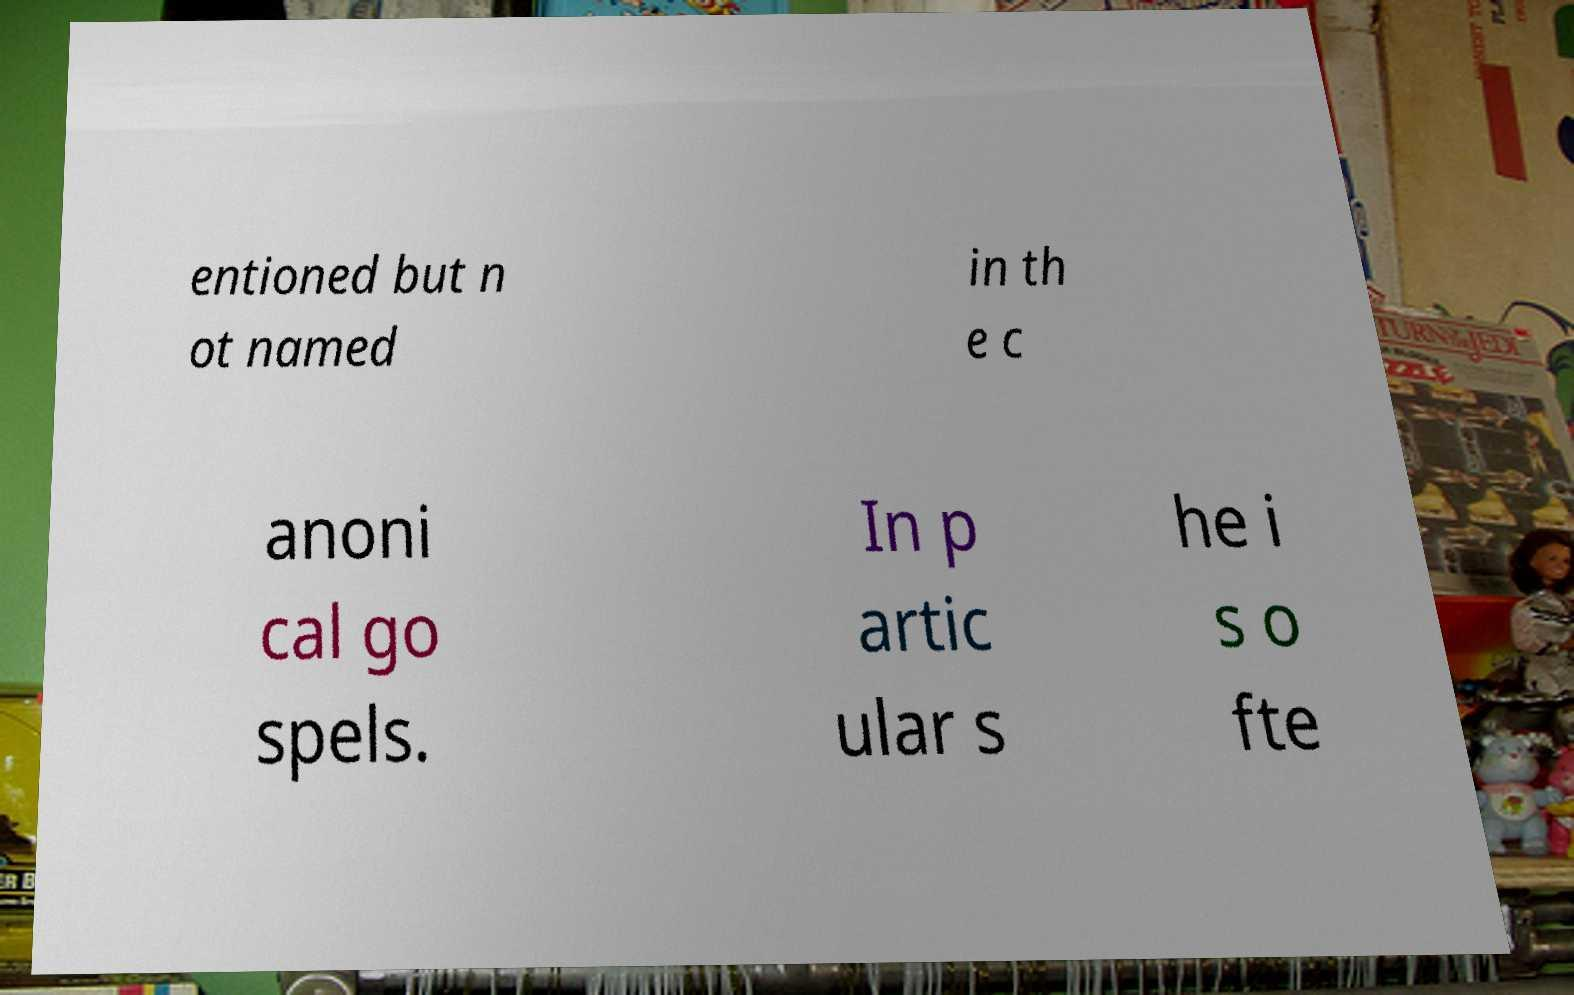For documentation purposes, I need the text within this image transcribed. Could you provide that? entioned but n ot named in th e c anoni cal go spels. In p artic ular s he i s o fte 